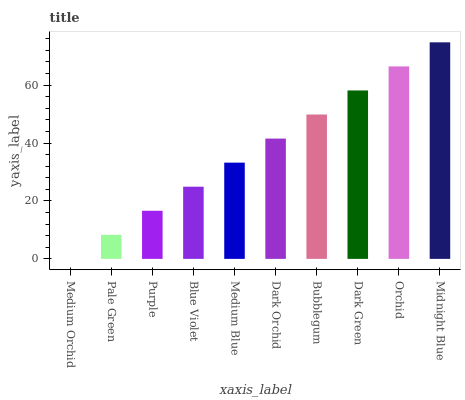Is Medium Orchid the minimum?
Answer yes or no. Yes. Is Midnight Blue the maximum?
Answer yes or no. Yes. Is Pale Green the minimum?
Answer yes or no. No. Is Pale Green the maximum?
Answer yes or no. No. Is Pale Green greater than Medium Orchid?
Answer yes or no. Yes. Is Medium Orchid less than Pale Green?
Answer yes or no. Yes. Is Medium Orchid greater than Pale Green?
Answer yes or no. No. Is Pale Green less than Medium Orchid?
Answer yes or no. No. Is Dark Orchid the high median?
Answer yes or no. Yes. Is Medium Blue the low median?
Answer yes or no. Yes. Is Orchid the high median?
Answer yes or no. No. Is Bubblegum the low median?
Answer yes or no. No. 